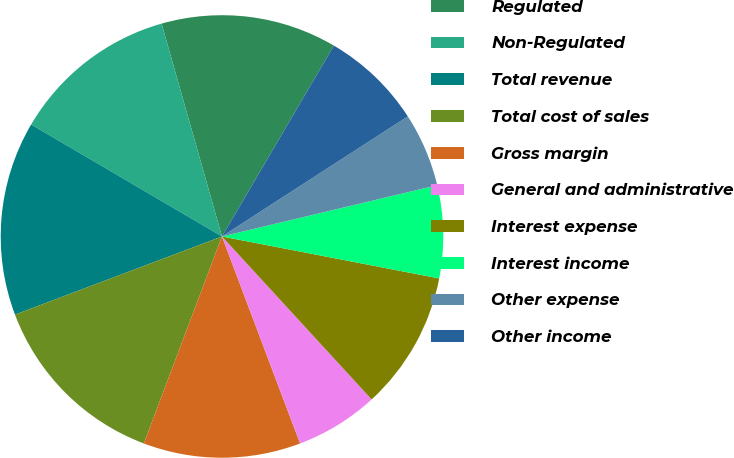Convert chart to OTSL. <chart><loc_0><loc_0><loc_500><loc_500><pie_chart><fcel>Regulated<fcel>Non-Regulated<fcel>Total revenue<fcel>Total cost of sales<fcel>Gross margin<fcel>General and administrative<fcel>Interest expense<fcel>Interest income<fcel>Other expense<fcel>Other income<nl><fcel>12.84%<fcel>12.16%<fcel>14.19%<fcel>13.51%<fcel>11.49%<fcel>6.08%<fcel>10.14%<fcel>6.76%<fcel>5.41%<fcel>7.43%<nl></chart> 